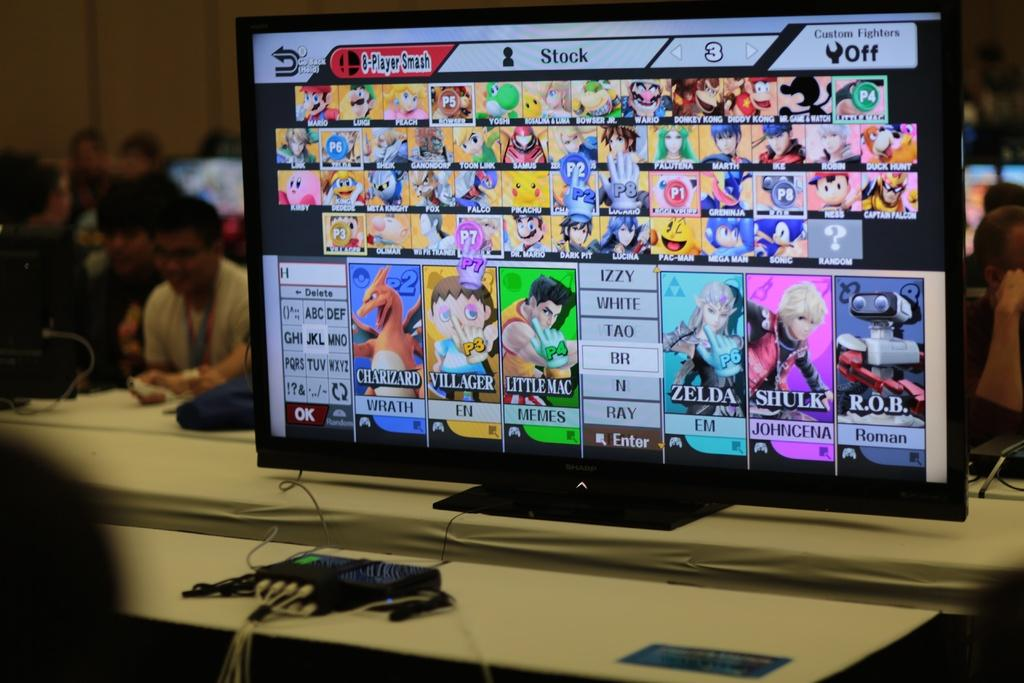Provide a one-sentence caption for the provided image. A monitor shows anime characters, including Charizard and Zelda. 